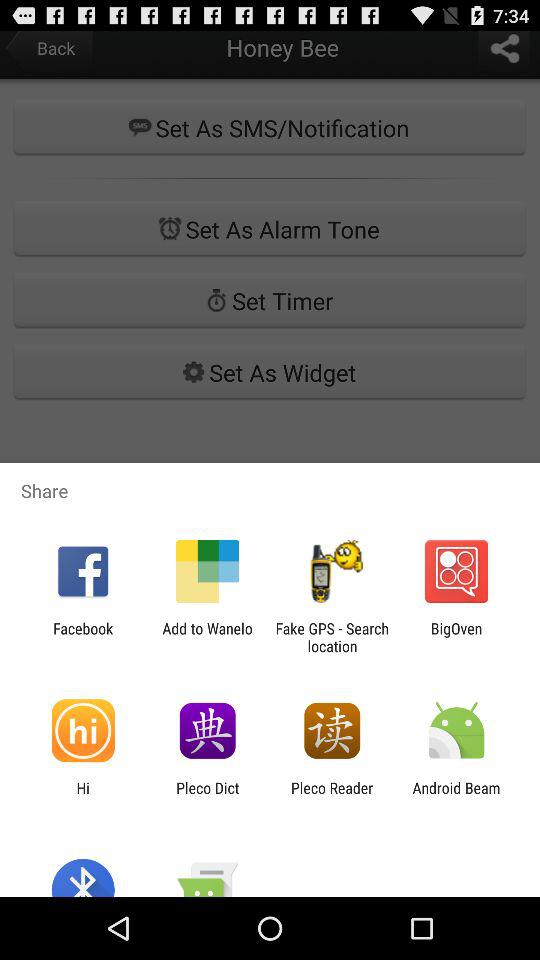What applications can we use to share? You can use "Facebook", "Add to Wanelo", "Fake GPS - Search location", "BigOven", "Hi", "Pleco Dict", "Pleco Reader" and "Android Beam". 